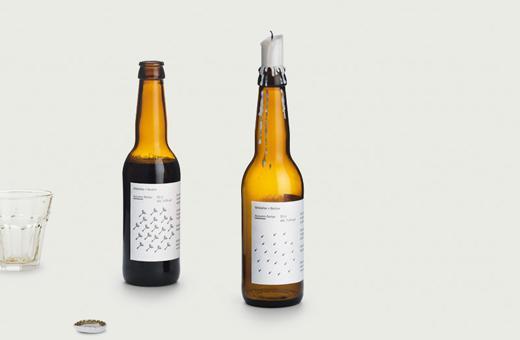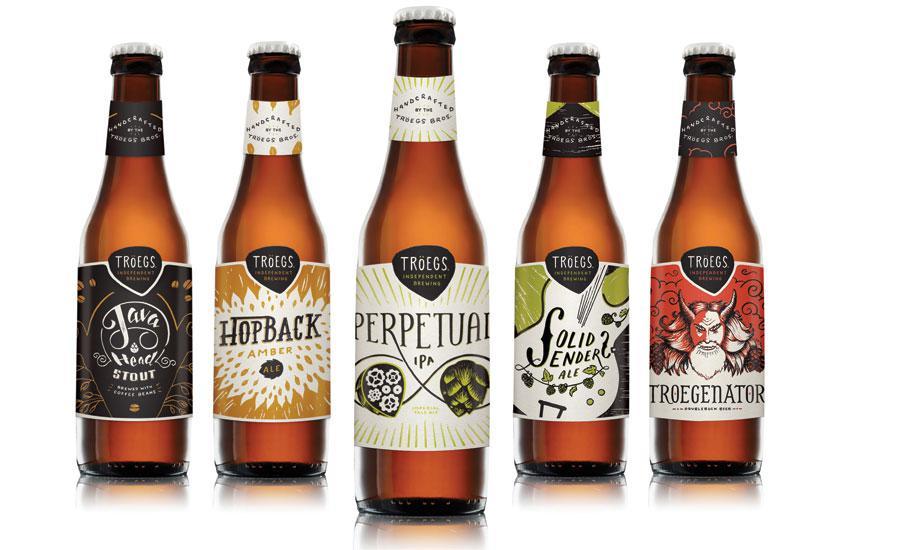The first image is the image on the left, the second image is the image on the right. Examine the images to the left and right. Is the description "One of the images shows a glass next to a bottle of beer and the other image shows a row of beer bottles." accurate? Answer yes or no. Yes. The first image is the image on the left, the second image is the image on the right. Analyze the images presented: Is the assertion "One image contains only two containers of beer." valid? Answer yes or no. Yes. 